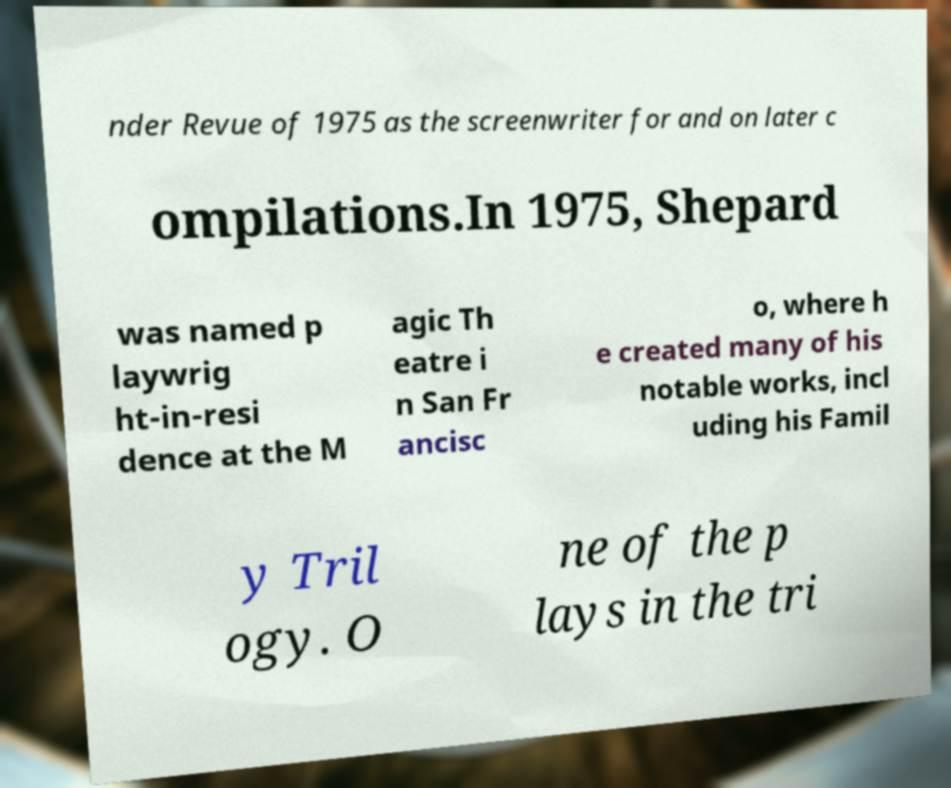What messages or text are displayed in this image? I need them in a readable, typed format. nder Revue of 1975 as the screenwriter for and on later c ompilations.In 1975, Shepard was named p laywrig ht-in-resi dence at the M agic Th eatre i n San Fr ancisc o, where h e created many of his notable works, incl uding his Famil y Tril ogy. O ne of the p lays in the tri 